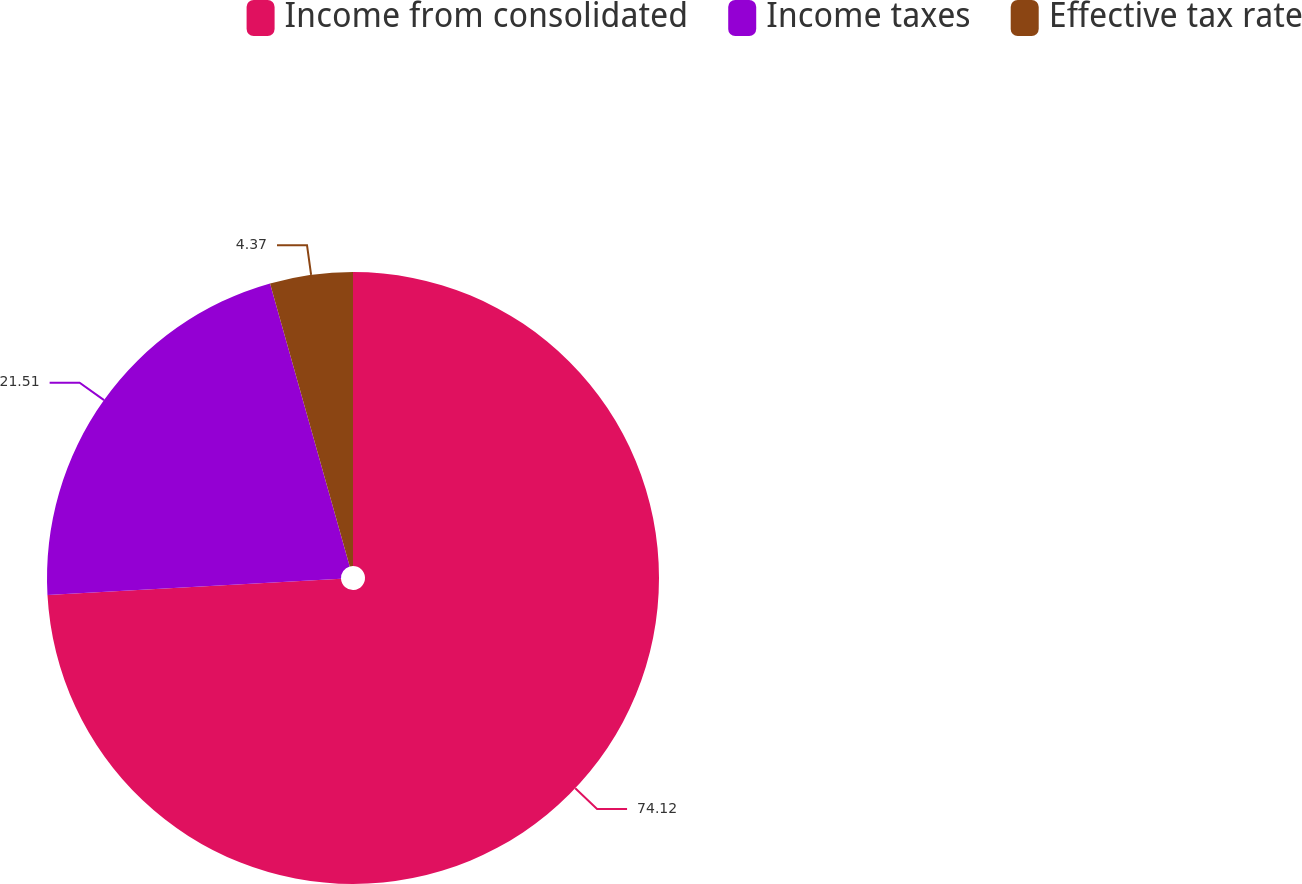<chart> <loc_0><loc_0><loc_500><loc_500><pie_chart><fcel>Income from consolidated<fcel>Income taxes<fcel>Effective tax rate<nl><fcel>74.12%<fcel>21.51%<fcel>4.37%<nl></chart> 